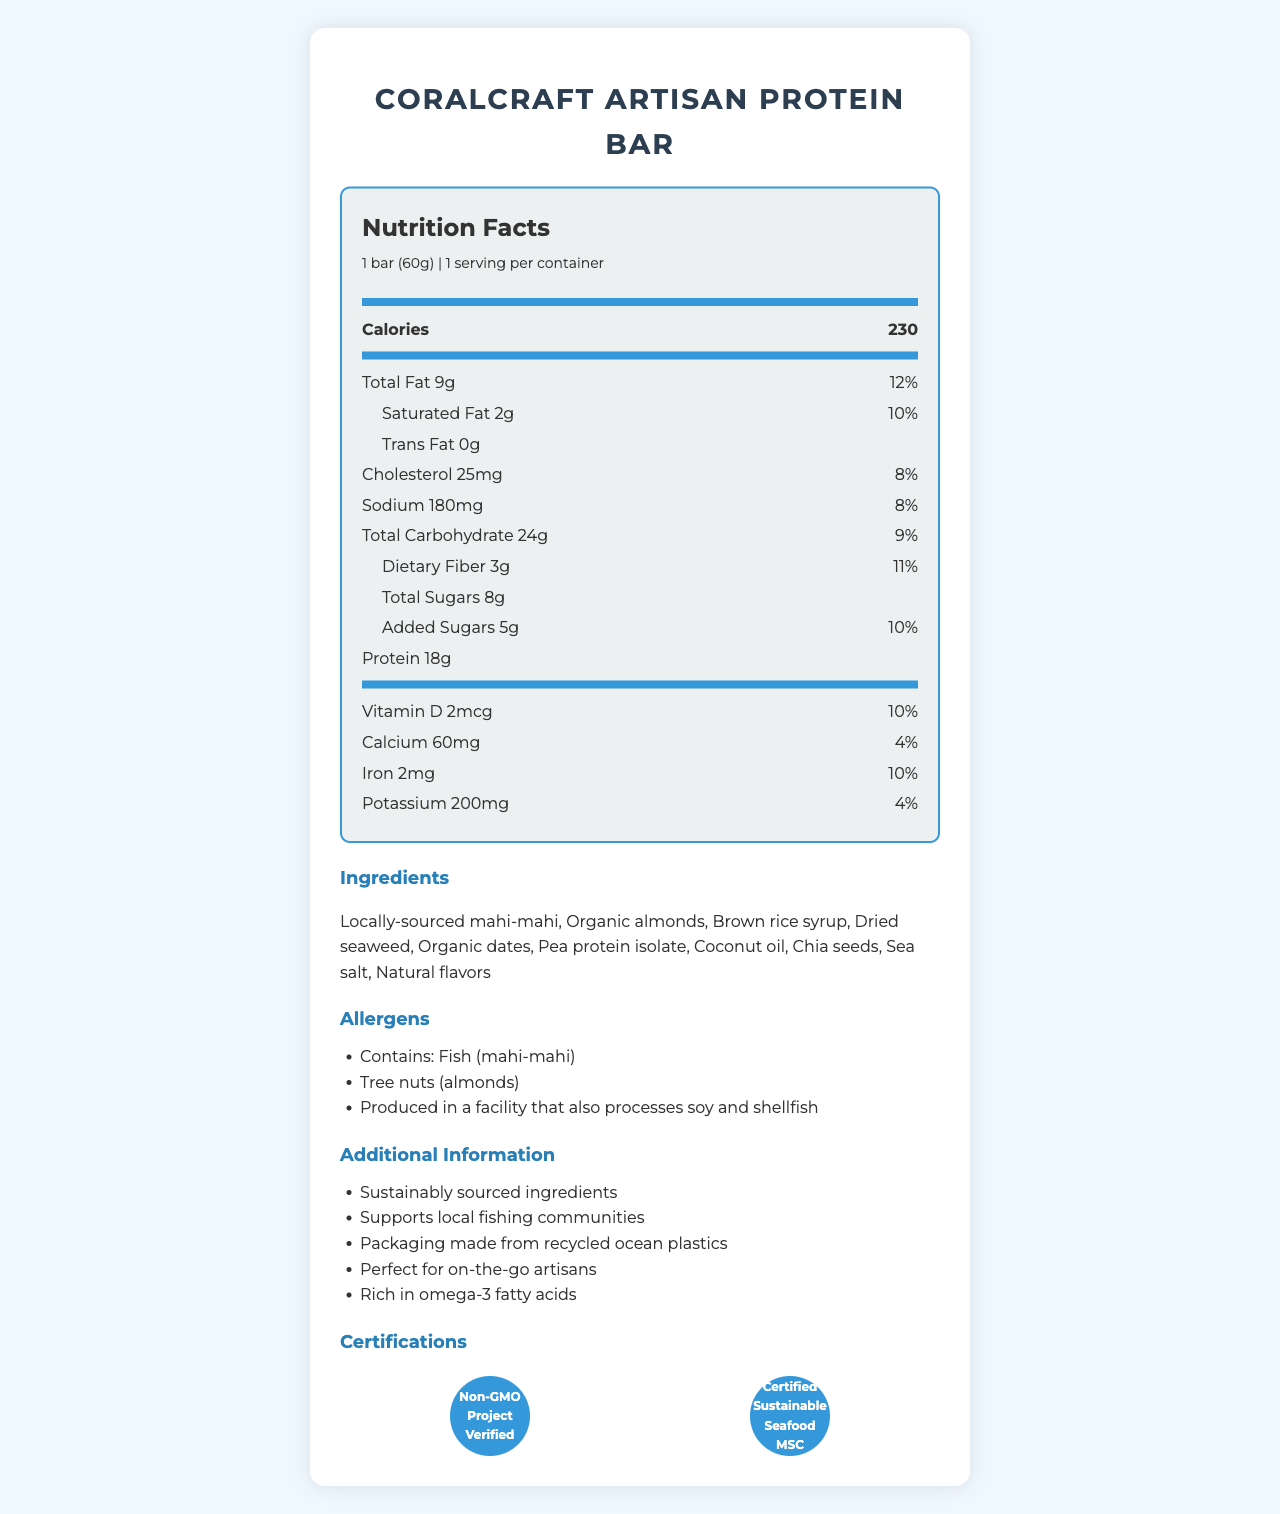what is the serving size of the CoralCraft Artisan Protein Bar? The serving size is clearly stated on the document as "1 bar (60g)".
Answer: 1 bar (60g) how many calories are in one serving of the CoralCraft Artisan Protein Bar? The document lists the total calories as 230.
Answer: 230 how much total fat does this protein bar contain? The total fat amount is shown as 9g on the document.
Answer: 9g what percentage of the daily value of dietary fiber does this bar provide? The daily value percentage for dietary fiber is noted as 11%.
Answer: 11% what are the first two ingredients of the bar? The document lists the ingredients in order, with the first two being "Locally-sourced mahi-mahi" and "Organic almonds".
Answer: Locally-sourced mahi-mahi, Organic almonds how many grams of protein are in the CoralCraft Artisan Protein Bar? The nutrition facts indicate 18g of protein.
Answer: 18g which ingredient is listed last in the ingredients section? The last ingredient in the list is "Natural flavors".
Answer: Natural flavors what is the total carbohydrate content in this bar? The document lists the total carbohydrate content as 24g.
Answer: 24g What ingredients are labeled as containing allergens? The allergens section specifies "Fish (mahi-mahi)" and "Tree nuts (almonds)".
Answer: Fish (mahi-mahi), Tree nuts (almonds) what type of facility is this product produced in? The allergens section notes that the product is produced in a facility that also processes soy and shellfish.
Answer: Produced in a facility that also processes soy and shellfish the certification logos include which of the following? A. USDA Organic B. Non-GMO Project Verified C. Certified Gluten-Free D. Certified Sustainable Seafood MSC The certification logos shown include "Non-GMO Project Verified" and "Certified Sustainable Seafood MSC".
Answer: B, D how much cholesterol does one serving contain? A. 10mg B. 15mg C. 25mg D. 35mg The nutritional information states that one serving contains 25mg of cholesterol.
Answer: C is the CoralCraft Artisan Protein Bar suitable for someone with a fish allergy? The product contains fish (mahi-mahi), as stated in the allergens section.
Answer: No does this product support local fishing communities, and what other sustainable practices are mentioned? The document mentions "Supports local fishing communities" and other practices like "Sustainably sourced ingredients" and "Packaging made from recycled ocean plastics".
Answer: Yes summarize the main focus of this Nutrition Facts Label. The document focuses on presenting the nutritional value, ingredients, allergens, and sustainability aspects of the CoralCraft Artisan Protein Bar in a detailed manner.
Answer: The CoralCraft Artisan Protein Bar is a nutritious, sustainably-sourced snack designed for busy artisans. It provides 230 calories with a balanced content of proteins, fats, and carbohydrates per 60g serving. Important ingredients and allergens are noted, along with sustainability certifications and additional benefits such as support for local fishing communities. how many servings are contained in one package? The document states that there is 1 serving per container.
Answer: 1 does this product contain any added sugars? The document lists added sugars as 5g with a daily value percentage of 10%.
Answer: Yes how many grams of saturated fat are present in the bar? The amount of saturated fat shown is 2g.
Answer: 2g is there any information about how this product supports local communities? The document states that the product supports local fishing communities.
Answer: Yes how does the packaging contribute to environmental sustainability? The document mentions "Packaging made from recycled ocean plastics" as a sustainable practice.
Answer: The packaging is made from recycled ocean plastics. what is the daily value percentage of calcium in one bar? A. 2% B. 4% C. 6% D. 8% The daily value percentage for calcium is listed as 4%.
Answer: B what are the certification logos present in the document? The certification logos include "Non-GMO Project Verified" and "Certified Sustainable Seafood MSC".
Answer: Non-GMO Project Verified, Certified Sustainable Seafood MSC how many grams of total sugars does the CoralCraft Artisan Protein Bar contain? The document lists the total sugars content as 8g.
Answer: 8g what is the daily value percentage of sodium in the bar? The sodium content has a daily value percentage of 8%.
Answer: 8% does the nutrition label mention any omega-3 fatty acids content? The additional information section states that the product is "Rich in omega-3 fatty acids".
Answer: Yes, it mentions that the bar is rich in omega-3 fatty acids. what is the main source of protein in this bar? The ingredients list mentions "Locally-sourced mahi-mahi" and "Pea protein isolate", which are likely the main sources of protein.
Answer: The main sources appear to be Locally-sourced mahi-mahi and Pea protein isolate. 